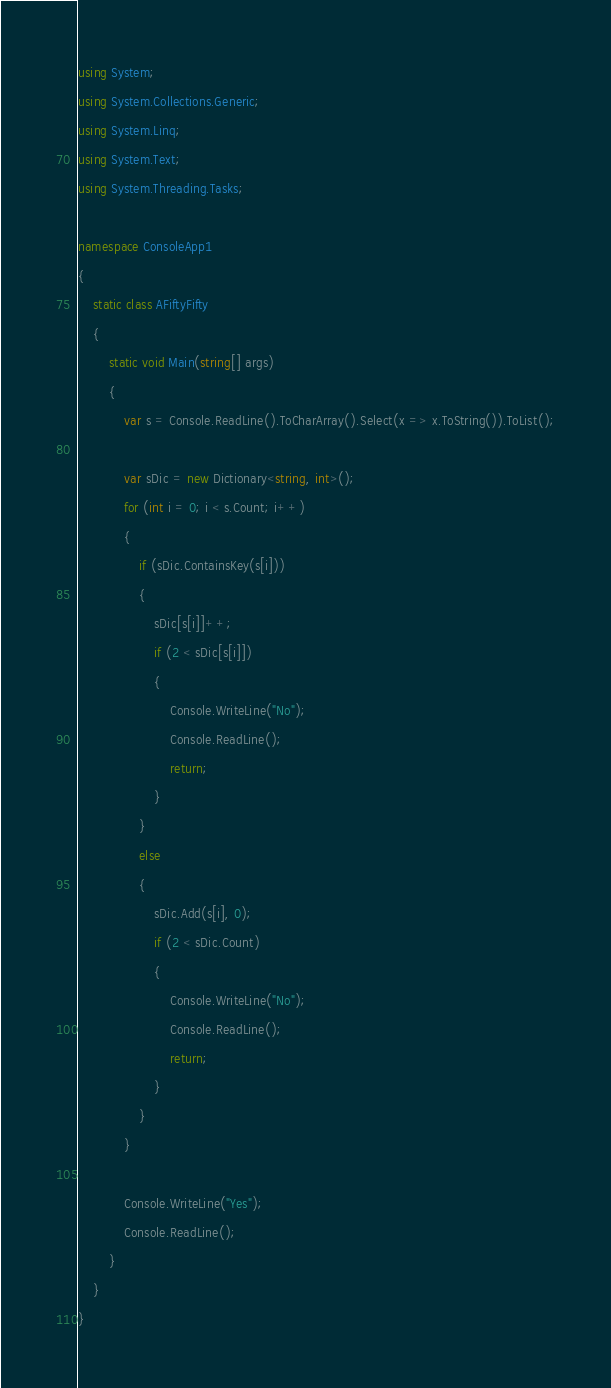Convert code to text. <code><loc_0><loc_0><loc_500><loc_500><_C#_>using System;
using System.Collections.Generic;
using System.Linq;
using System.Text;
using System.Threading.Tasks;

namespace ConsoleApp1
{
    static class AFiftyFifty
    {
        static void Main(string[] args)
        {
            var s = Console.ReadLine().ToCharArray().Select(x => x.ToString()).ToList();

            var sDic = new Dictionary<string, int>();
            for (int i = 0; i < s.Count; i++)
            {
                if (sDic.ContainsKey(s[i]))
                {
                    sDic[s[i]]++;
                    if (2 < sDic[s[i]])
                    {
                        Console.WriteLine("No");
                        Console.ReadLine();
                        return;
                    }
                }
                else
                {
                    sDic.Add(s[i], 0);
                    if (2 < sDic.Count)
                    {
                        Console.WriteLine("No");
                        Console.ReadLine();
                        return;
                    }
                }
            }

            Console.WriteLine("Yes");
            Console.ReadLine();
        }
    }
}</code> 